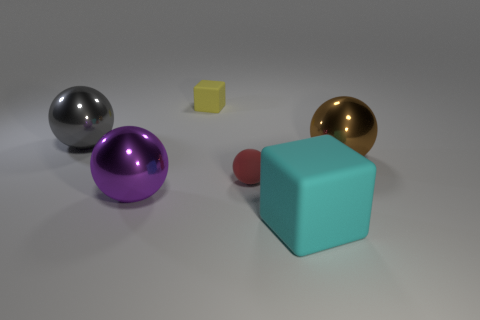Are there an equal number of matte spheres in front of the large cyan cube and large metal things?
Offer a very short reply. No. Are the big thing on the right side of the large cyan matte block and the yellow thing left of the brown metal object made of the same material?
Provide a short and direct response. No. There is a big shiny thing that is to the right of the big cyan matte block; is it the same shape as the tiny yellow matte object that is behind the big rubber thing?
Keep it short and to the point. No. Is the number of cubes that are behind the brown object less than the number of tiny blue cylinders?
Your answer should be very brief. No. What number of spheres are the same color as the large rubber object?
Make the answer very short. 0. What size is the metal sphere that is to the right of the small red thing?
Give a very brief answer. Large. There is a tiny matte thing in front of the small rubber thing that is behind the metallic thing that is on the right side of the tiny yellow block; what shape is it?
Offer a very short reply. Sphere. There is a large thing that is to the right of the small rubber block and to the left of the large brown metal sphere; what is its shape?
Make the answer very short. Cube. Is there a gray ball that has the same size as the red rubber object?
Provide a succinct answer. No. There is a shiny object in front of the red matte thing; is its shape the same as the big gray shiny thing?
Make the answer very short. Yes. 